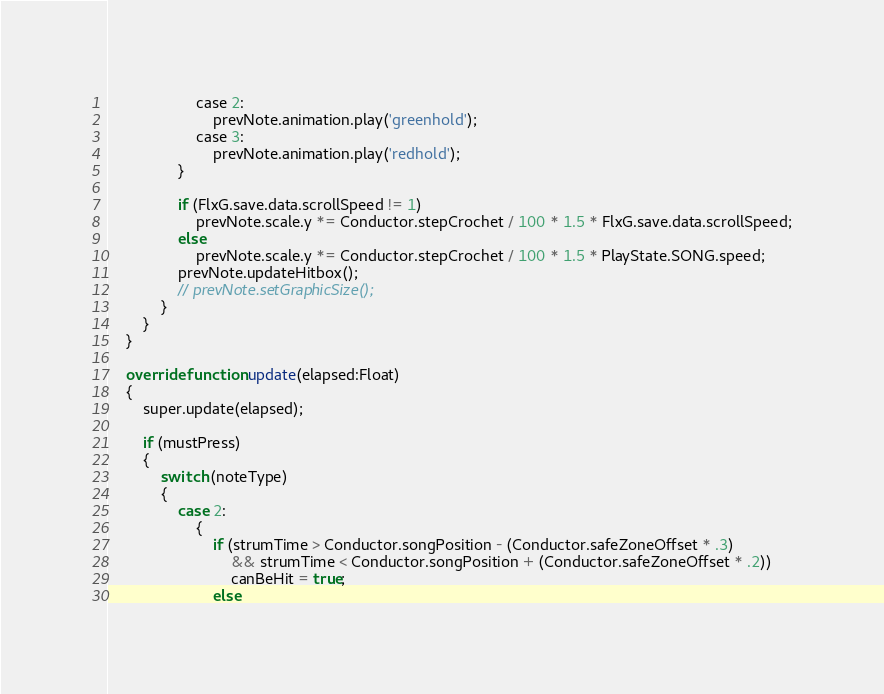Convert code to text. <code><loc_0><loc_0><loc_500><loc_500><_Haxe_>					case 2:
						prevNote.animation.play('greenhold');
					case 3:
						prevNote.animation.play('redhold');
				}

				if (FlxG.save.data.scrollSpeed != 1)
					prevNote.scale.y *= Conductor.stepCrochet / 100 * 1.5 * FlxG.save.data.scrollSpeed;
				else
					prevNote.scale.y *= Conductor.stepCrochet / 100 * 1.5 * PlayState.SONG.speed;
				prevNote.updateHitbox();
				// prevNote.setGraphicSize();
			}
		}
	}

	override function update(elapsed:Float)
	{
		super.update(elapsed);

		if (mustPress)
		{
			switch (noteType)
			{
				case 2:
					{
						if (strumTime > Conductor.songPosition - (Conductor.safeZoneOffset * .3)
							&& strumTime < Conductor.songPosition + (Conductor.safeZoneOffset * .2))
							canBeHit = true;
						else</code> 